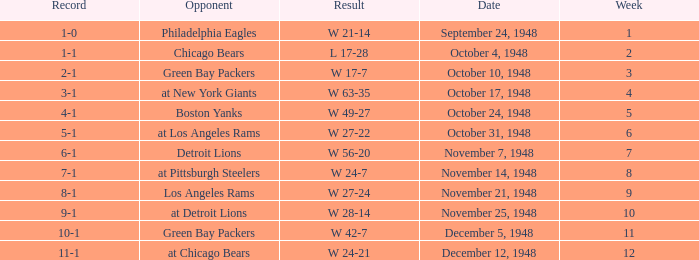What date was the opponent the Boston Yanks? October 24, 1948. 